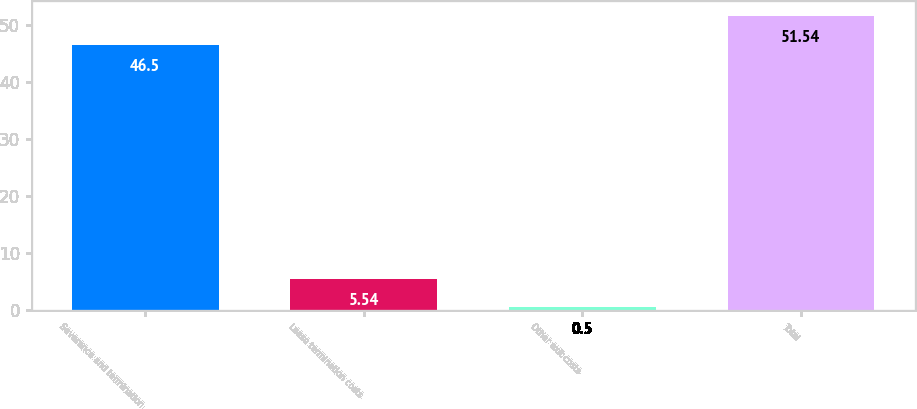<chart> <loc_0><loc_0><loc_500><loc_500><bar_chart><fcel>Severance and termination<fcel>Lease termination costs<fcel>Other exit costs<fcel>Total<nl><fcel>46.5<fcel>5.54<fcel>0.5<fcel>51.54<nl></chart> 